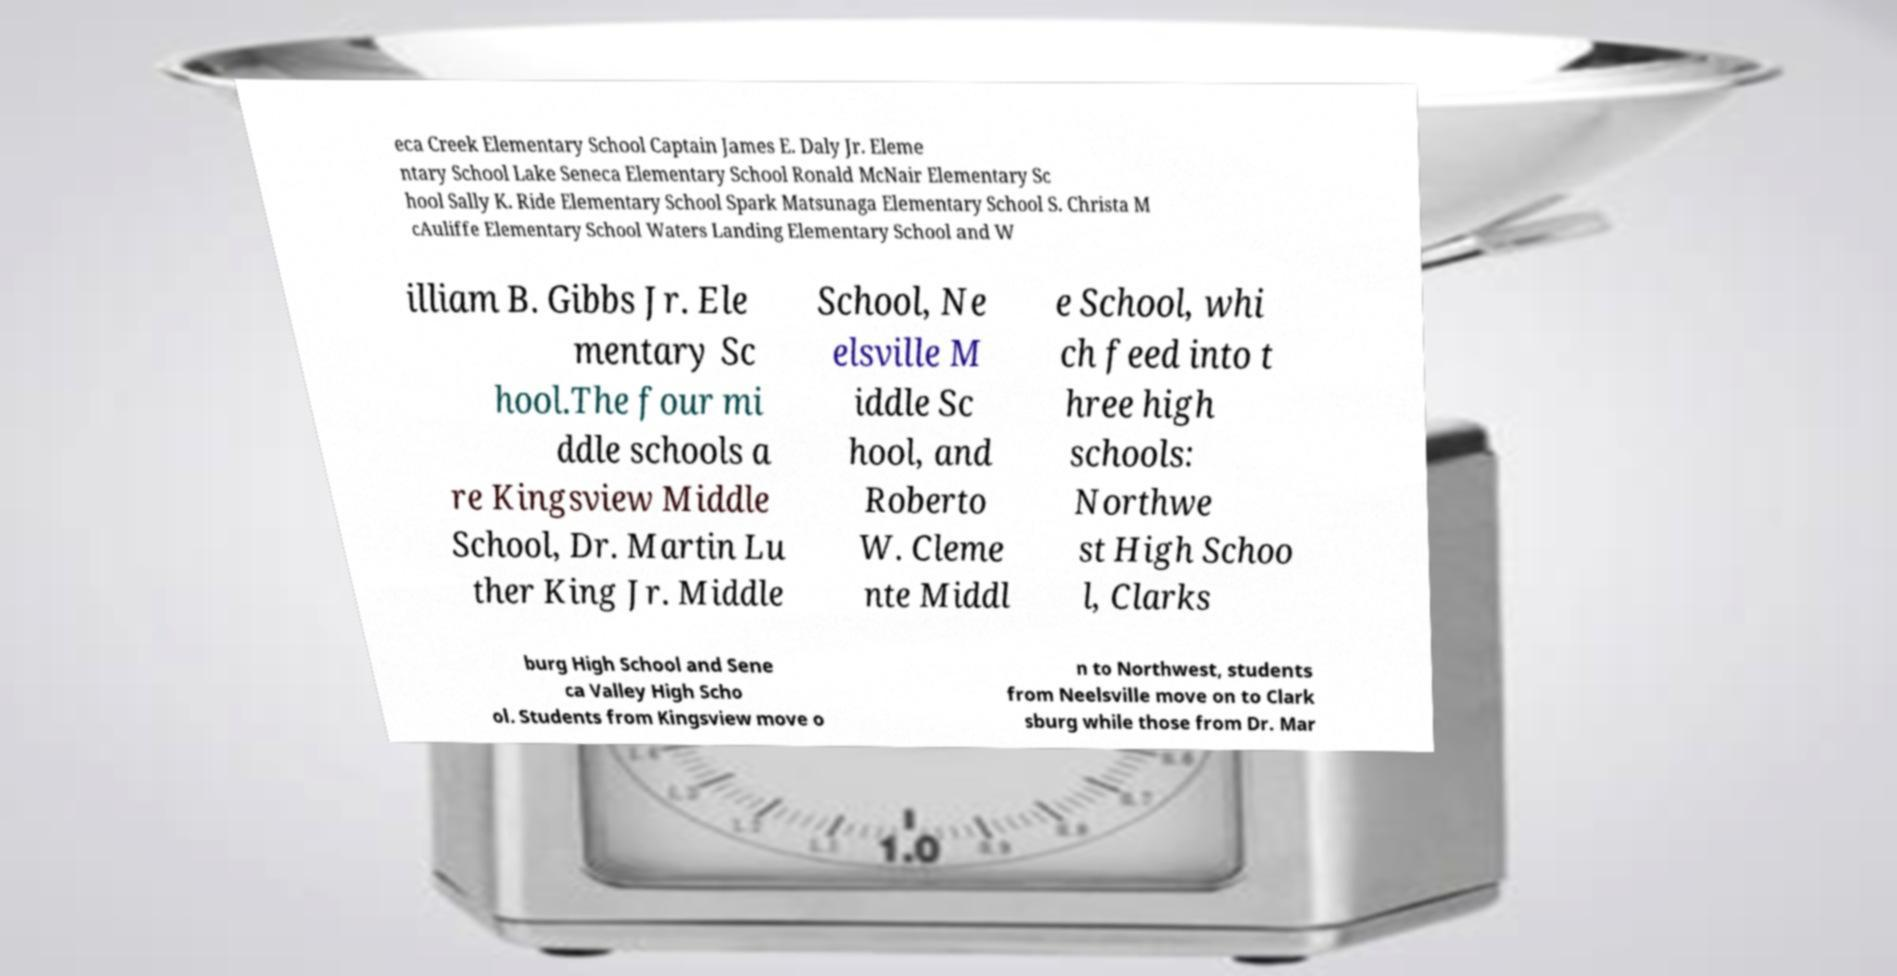Can you accurately transcribe the text from the provided image for me? eca Creek Elementary School Captain James E. Daly Jr. Eleme ntary School Lake Seneca Elementary School Ronald McNair Elementary Sc hool Sally K. Ride Elementary School Spark Matsunaga Elementary School S. Christa M cAuliffe Elementary School Waters Landing Elementary School and W illiam B. Gibbs Jr. Ele mentary Sc hool.The four mi ddle schools a re Kingsview Middle School, Dr. Martin Lu ther King Jr. Middle School, Ne elsville M iddle Sc hool, and Roberto W. Cleme nte Middl e School, whi ch feed into t hree high schools: Northwe st High Schoo l, Clarks burg High School and Sene ca Valley High Scho ol. Students from Kingsview move o n to Northwest, students from Neelsville move on to Clark sburg while those from Dr. Mar 